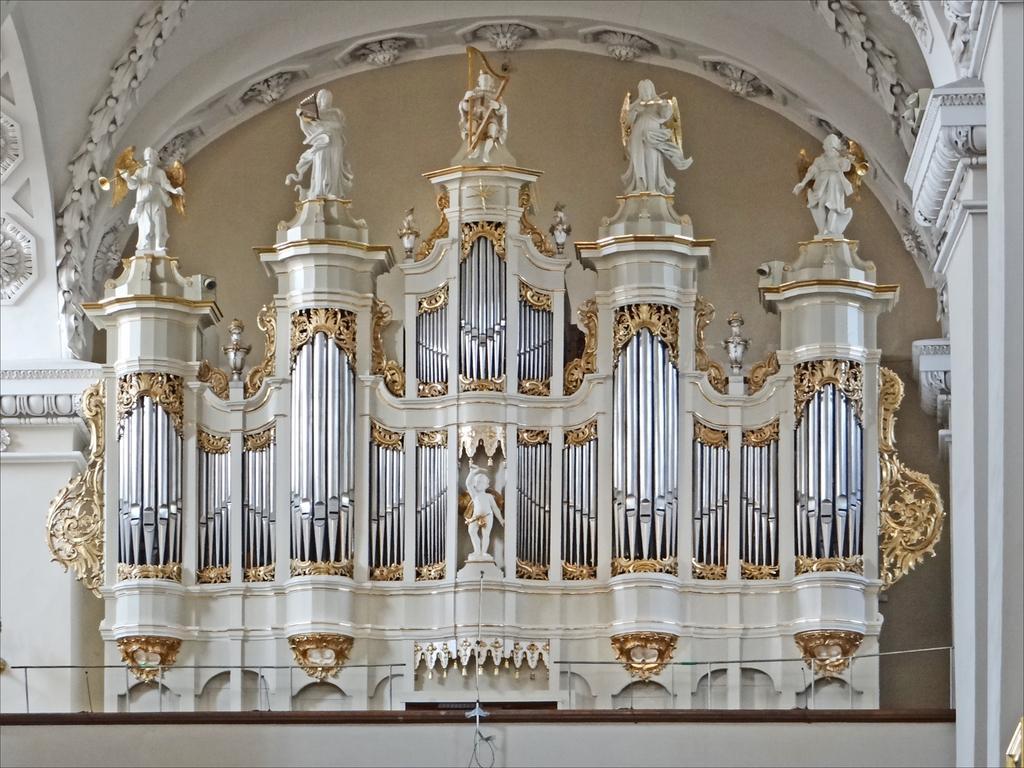In one or two sentences, can you explain what this image depicts? In this picture I can see inner view of a building and I can see few carvings on the ceiling and I can see few statues. 